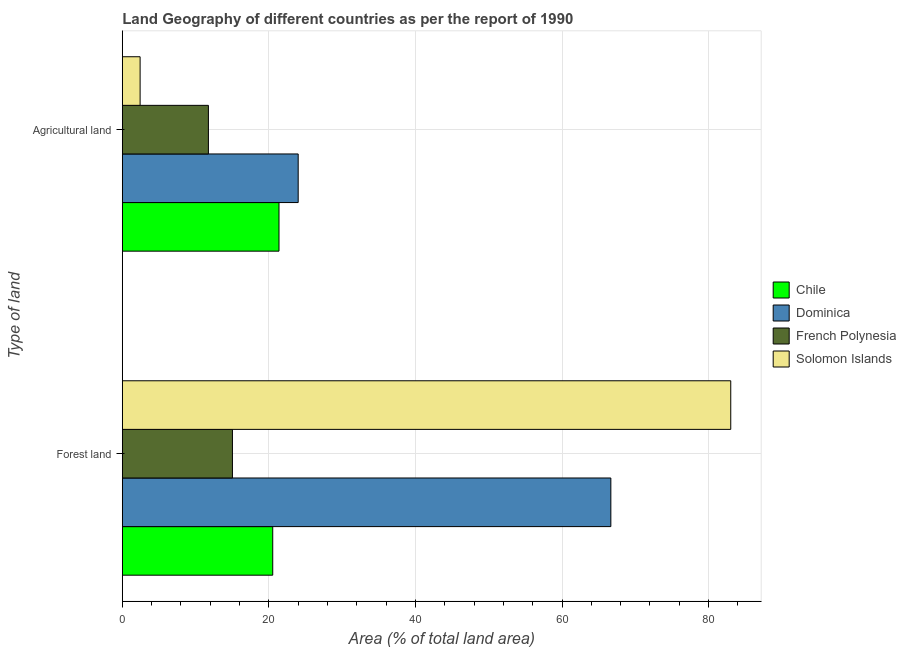How many different coloured bars are there?
Offer a very short reply. 4. How many bars are there on the 1st tick from the top?
Offer a terse response. 4. How many bars are there on the 1st tick from the bottom?
Offer a very short reply. 4. What is the label of the 2nd group of bars from the top?
Your answer should be very brief. Forest land. What is the percentage of land area under agriculture in Solomon Islands?
Provide a succinct answer. 2.43. Across all countries, what is the maximum percentage of land area under agriculture?
Offer a terse response. 24. Across all countries, what is the minimum percentage of land area under agriculture?
Provide a succinct answer. 2.43. In which country was the percentage of land area under forests maximum?
Your response must be concise. Solomon Islands. In which country was the percentage of land area under forests minimum?
Offer a terse response. French Polynesia. What is the total percentage of land area under forests in the graph?
Make the answer very short. 185.25. What is the difference between the percentage of land area under forests in Chile and that in Solomon Islands?
Provide a short and direct response. -62.5. What is the difference between the percentage of land area under agriculture in Chile and the percentage of land area under forests in Dominica?
Your answer should be very brief. -45.28. What is the average percentage of land area under agriculture per country?
Provide a succinct answer. 14.89. What is the difference between the percentage of land area under forests and percentage of land area under agriculture in Solomon Islands?
Provide a succinct answer. 80.6. In how many countries, is the percentage of land area under forests greater than 56 %?
Your answer should be very brief. 2. What is the ratio of the percentage of land area under agriculture in Chile to that in Solomon Islands?
Make the answer very short. 8.8. In how many countries, is the percentage of land area under agriculture greater than the average percentage of land area under agriculture taken over all countries?
Keep it short and to the point. 2. What does the 1st bar from the top in Agricultural land represents?
Your answer should be very brief. Solomon Islands. What does the 1st bar from the bottom in Forest land represents?
Your answer should be compact. Chile. How many bars are there?
Make the answer very short. 8. Are all the bars in the graph horizontal?
Your answer should be very brief. Yes. How many countries are there in the graph?
Your answer should be very brief. 4. Does the graph contain any zero values?
Give a very brief answer. No. Does the graph contain grids?
Provide a short and direct response. Yes. Where does the legend appear in the graph?
Offer a terse response. Center right. What is the title of the graph?
Offer a terse response. Land Geography of different countries as per the report of 1990. What is the label or title of the X-axis?
Provide a short and direct response. Area (% of total land area). What is the label or title of the Y-axis?
Provide a short and direct response. Type of land. What is the Area (% of total land area) of Chile in Forest land?
Provide a short and direct response. 20.53. What is the Area (% of total land area) of Dominica in Forest land?
Offer a very short reply. 66.67. What is the Area (% of total land area) in French Polynesia in Forest land?
Make the answer very short. 15.03. What is the Area (% of total land area) of Solomon Islands in Forest land?
Ensure brevity in your answer.  83.03. What is the Area (% of total land area) of Chile in Agricultural land?
Ensure brevity in your answer.  21.38. What is the Area (% of total land area) in French Polynesia in Agricultural land?
Offer a terse response. 11.75. What is the Area (% of total land area) in Solomon Islands in Agricultural land?
Keep it short and to the point. 2.43. Across all Type of land, what is the maximum Area (% of total land area) of Chile?
Give a very brief answer. 21.38. Across all Type of land, what is the maximum Area (% of total land area) in Dominica?
Provide a succinct answer. 66.67. Across all Type of land, what is the maximum Area (% of total land area) of French Polynesia?
Keep it short and to the point. 15.03. Across all Type of land, what is the maximum Area (% of total land area) in Solomon Islands?
Give a very brief answer. 83.03. Across all Type of land, what is the minimum Area (% of total land area) of Chile?
Your response must be concise. 20.53. Across all Type of land, what is the minimum Area (% of total land area) in Dominica?
Provide a short and direct response. 24. Across all Type of land, what is the minimum Area (% of total land area) of French Polynesia?
Give a very brief answer. 11.75. Across all Type of land, what is the minimum Area (% of total land area) in Solomon Islands?
Your response must be concise. 2.43. What is the total Area (% of total land area) in Chile in the graph?
Offer a very short reply. 41.91. What is the total Area (% of total land area) of Dominica in the graph?
Provide a short and direct response. 90.67. What is the total Area (% of total land area) of French Polynesia in the graph?
Your response must be concise. 26.78. What is the total Area (% of total land area) in Solomon Islands in the graph?
Make the answer very short. 85.46. What is the difference between the Area (% of total land area) of Chile in Forest land and that in Agricultural land?
Give a very brief answer. -0.86. What is the difference between the Area (% of total land area) of Dominica in Forest land and that in Agricultural land?
Your response must be concise. 42.67. What is the difference between the Area (% of total land area) of French Polynesia in Forest land and that in Agricultural land?
Make the answer very short. 3.28. What is the difference between the Area (% of total land area) in Solomon Islands in Forest land and that in Agricultural land?
Offer a very short reply. 80.6. What is the difference between the Area (% of total land area) of Chile in Forest land and the Area (% of total land area) of Dominica in Agricultural land?
Give a very brief answer. -3.47. What is the difference between the Area (% of total land area) in Chile in Forest land and the Area (% of total land area) in French Polynesia in Agricultural land?
Offer a very short reply. 8.78. What is the difference between the Area (% of total land area) in Chile in Forest land and the Area (% of total land area) in Solomon Islands in Agricultural land?
Your answer should be very brief. 18.1. What is the difference between the Area (% of total land area) in Dominica in Forest land and the Area (% of total land area) in French Polynesia in Agricultural land?
Offer a very short reply. 54.92. What is the difference between the Area (% of total land area) of Dominica in Forest land and the Area (% of total land area) of Solomon Islands in Agricultural land?
Provide a short and direct response. 64.24. What is the difference between the Area (% of total land area) in French Polynesia in Forest land and the Area (% of total land area) in Solomon Islands in Agricultural land?
Your answer should be compact. 12.6. What is the average Area (% of total land area) of Chile per Type of land?
Ensure brevity in your answer.  20.96. What is the average Area (% of total land area) in Dominica per Type of land?
Your answer should be very brief. 45.33. What is the average Area (% of total land area) of French Polynesia per Type of land?
Your answer should be compact. 13.39. What is the average Area (% of total land area) of Solomon Islands per Type of land?
Give a very brief answer. 42.73. What is the difference between the Area (% of total land area) in Chile and Area (% of total land area) in Dominica in Forest land?
Offer a terse response. -46.14. What is the difference between the Area (% of total land area) in Chile and Area (% of total land area) in French Polynesia in Forest land?
Your answer should be compact. 5.5. What is the difference between the Area (% of total land area) in Chile and Area (% of total land area) in Solomon Islands in Forest land?
Ensure brevity in your answer.  -62.5. What is the difference between the Area (% of total land area) in Dominica and Area (% of total land area) in French Polynesia in Forest land?
Your answer should be very brief. 51.64. What is the difference between the Area (% of total land area) of Dominica and Area (% of total land area) of Solomon Islands in Forest land?
Your answer should be very brief. -16.36. What is the difference between the Area (% of total land area) in French Polynesia and Area (% of total land area) in Solomon Islands in Forest land?
Offer a terse response. -68. What is the difference between the Area (% of total land area) of Chile and Area (% of total land area) of Dominica in Agricultural land?
Your answer should be compact. -2.62. What is the difference between the Area (% of total land area) in Chile and Area (% of total land area) in French Polynesia in Agricultural land?
Provide a short and direct response. 9.63. What is the difference between the Area (% of total land area) of Chile and Area (% of total land area) of Solomon Islands in Agricultural land?
Your answer should be compact. 18.95. What is the difference between the Area (% of total land area) in Dominica and Area (% of total land area) in French Polynesia in Agricultural land?
Make the answer very short. 12.25. What is the difference between the Area (% of total land area) in Dominica and Area (% of total land area) in Solomon Islands in Agricultural land?
Offer a terse response. 21.57. What is the difference between the Area (% of total land area) of French Polynesia and Area (% of total land area) of Solomon Islands in Agricultural land?
Offer a very short reply. 9.32. What is the ratio of the Area (% of total land area) in Dominica in Forest land to that in Agricultural land?
Give a very brief answer. 2.78. What is the ratio of the Area (% of total land area) of French Polynesia in Forest land to that in Agricultural land?
Offer a terse response. 1.28. What is the ratio of the Area (% of total land area) of Solomon Islands in Forest land to that in Agricultural land?
Your answer should be compact. 34.18. What is the difference between the highest and the second highest Area (% of total land area) in Chile?
Provide a short and direct response. 0.86. What is the difference between the highest and the second highest Area (% of total land area) in Dominica?
Your answer should be compact. 42.67. What is the difference between the highest and the second highest Area (% of total land area) of French Polynesia?
Ensure brevity in your answer.  3.28. What is the difference between the highest and the second highest Area (% of total land area) in Solomon Islands?
Provide a succinct answer. 80.6. What is the difference between the highest and the lowest Area (% of total land area) of Chile?
Offer a terse response. 0.86. What is the difference between the highest and the lowest Area (% of total land area) in Dominica?
Offer a very short reply. 42.67. What is the difference between the highest and the lowest Area (% of total land area) in French Polynesia?
Your answer should be compact. 3.28. What is the difference between the highest and the lowest Area (% of total land area) in Solomon Islands?
Keep it short and to the point. 80.6. 